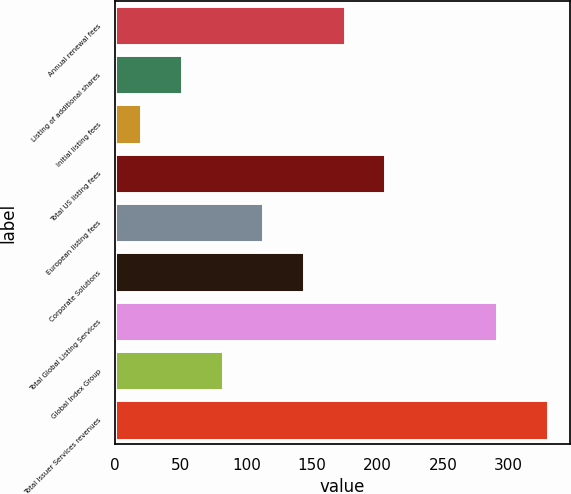Convert chart to OTSL. <chart><loc_0><loc_0><loc_500><loc_500><bar_chart><fcel>Annual renewal fees<fcel>Listing of additional shares<fcel>Initial listing fees<fcel>Total US listing fees<fcel>European listing fees<fcel>Corporate Solutions<fcel>Total Global Listing Services<fcel>Global Index Group<fcel>Total Issuer Services revenues<nl><fcel>175<fcel>51<fcel>20<fcel>206<fcel>113<fcel>144<fcel>291<fcel>82<fcel>330<nl></chart> 